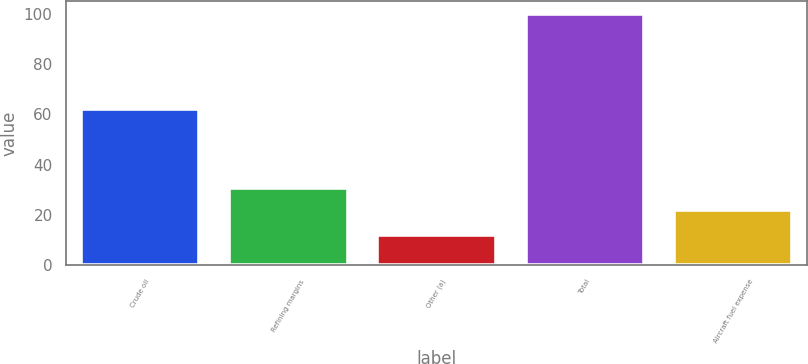<chart> <loc_0><loc_0><loc_500><loc_500><bar_chart><fcel>Crude oil<fcel>Refining margins<fcel>Other (a)<fcel>Total<fcel>Aircraft fuel expense<nl><fcel>62<fcel>30.8<fcel>12<fcel>100<fcel>22<nl></chart> 